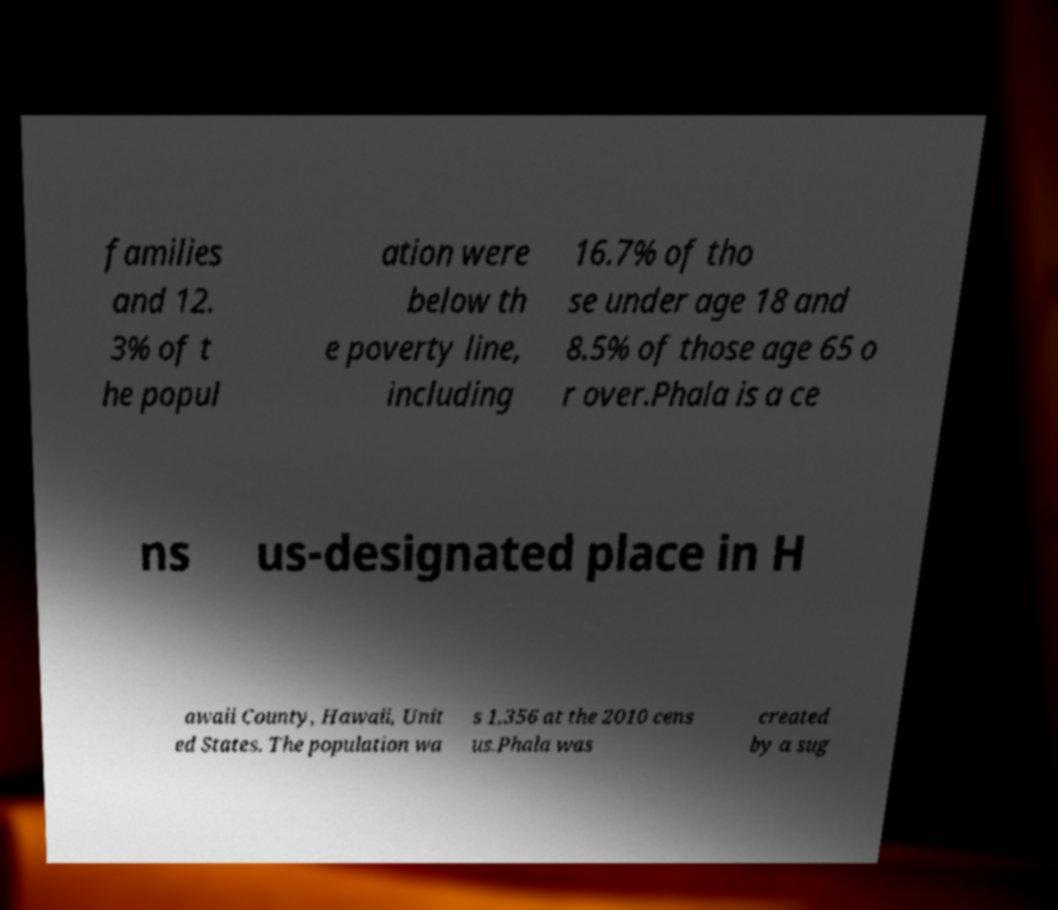For documentation purposes, I need the text within this image transcribed. Could you provide that? families and 12. 3% of t he popul ation were below th e poverty line, including 16.7% of tho se under age 18 and 8.5% of those age 65 o r over.Phala is a ce ns us-designated place in H awaii County, Hawaii, Unit ed States. The population wa s 1,356 at the 2010 cens us.Phala was created by a sug 